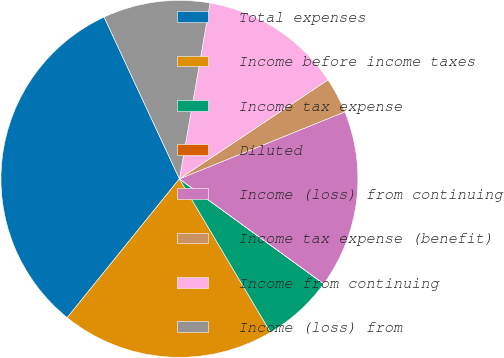Convert chart to OTSL. <chart><loc_0><loc_0><loc_500><loc_500><pie_chart><fcel>Total expenses<fcel>Income before income taxes<fcel>Income tax expense<fcel>Diluted<fcel>Income (loss) from continuing<fcel>Income tax expense (benefit)<fcel>Income from continuing<fcel>Income (loss) from<nl><fcel>32.24%<fcel>19.35%<fcel>6.46%<fcel>0.01%<fcel>16.13%<fcel>3.23%<fcel>12.9%<fcel>9.68%<nl></chart> 